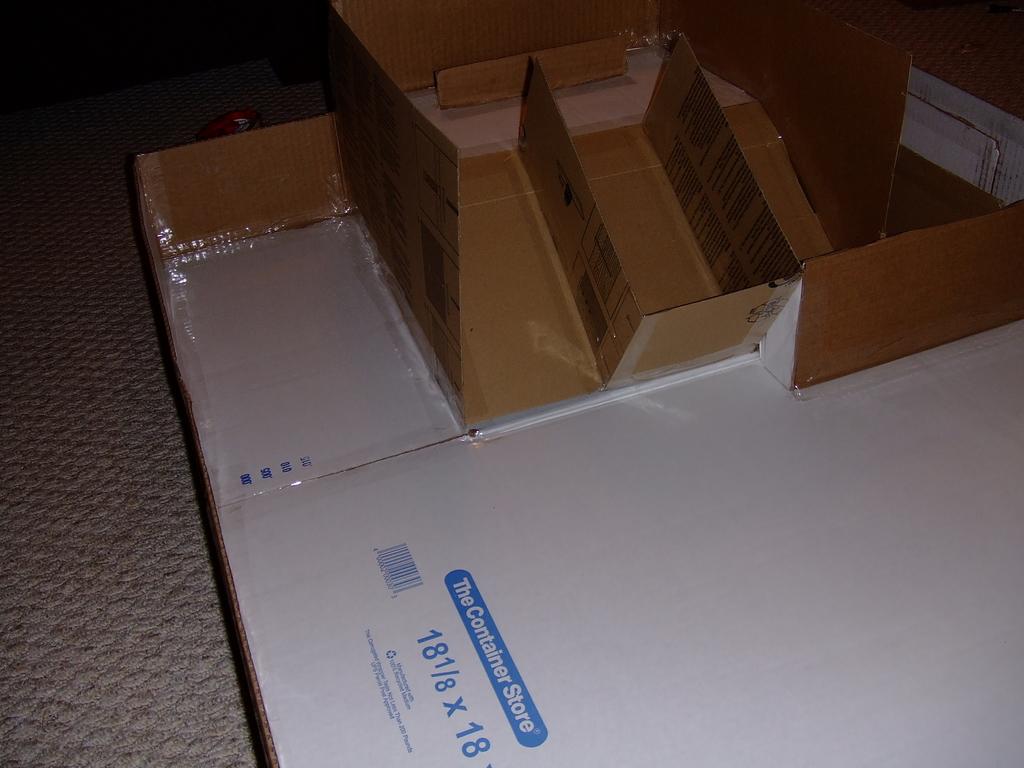Where is this box from?
Make the answer very short. The container store. What is the size of the box?
Provide a succinct answer. 18 1/8 x 18. 